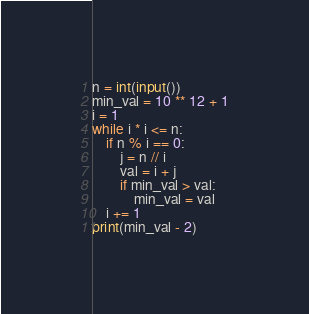<code> <loc_0><loc_0><loc_500><loc_500><_Python_>n = int(input())
min_val = 10 ** 12 + 1
i = 1
while i * i <= n:
    if n % i == 0:
        j = n // i
        val = i + j
        if min_val > val:
            min_val = val
    i += 1
print(min_val - 2)</code> 